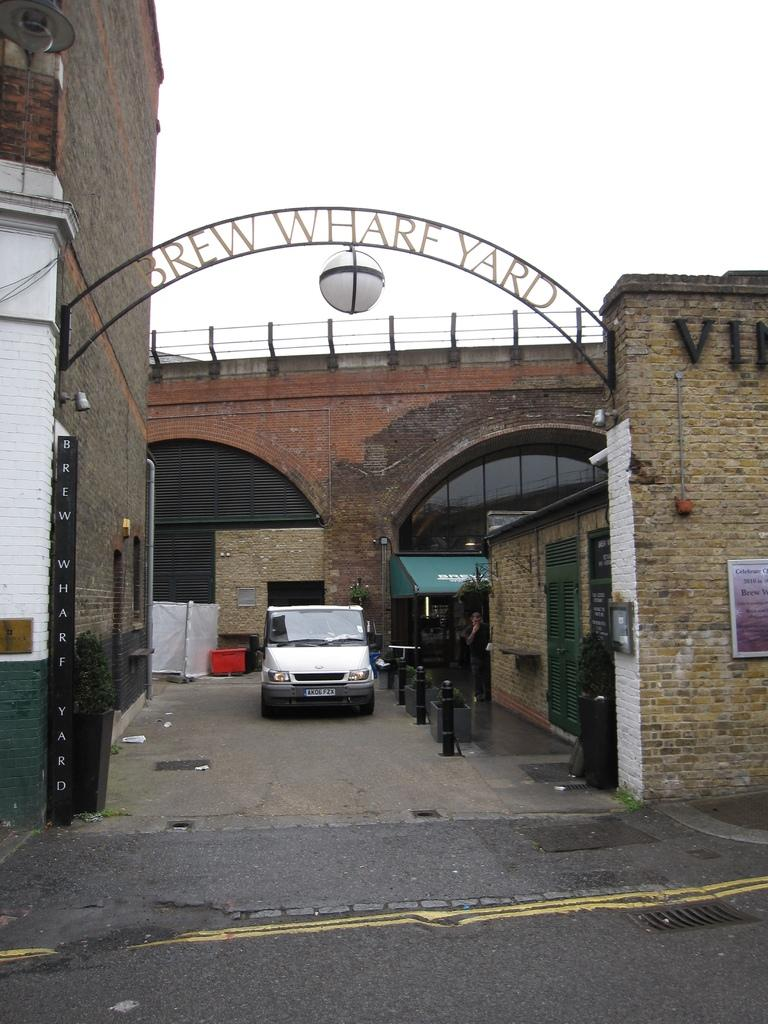What is the main subject of the image? There is a car on the road in the image. What can be seen in the background of the image? There is a building and the sky visible in the background of the image. What type of trouble is the car experiencing in the image? There is no indication of any trouble with the car in the image; it appears to be driving normally on the road. 